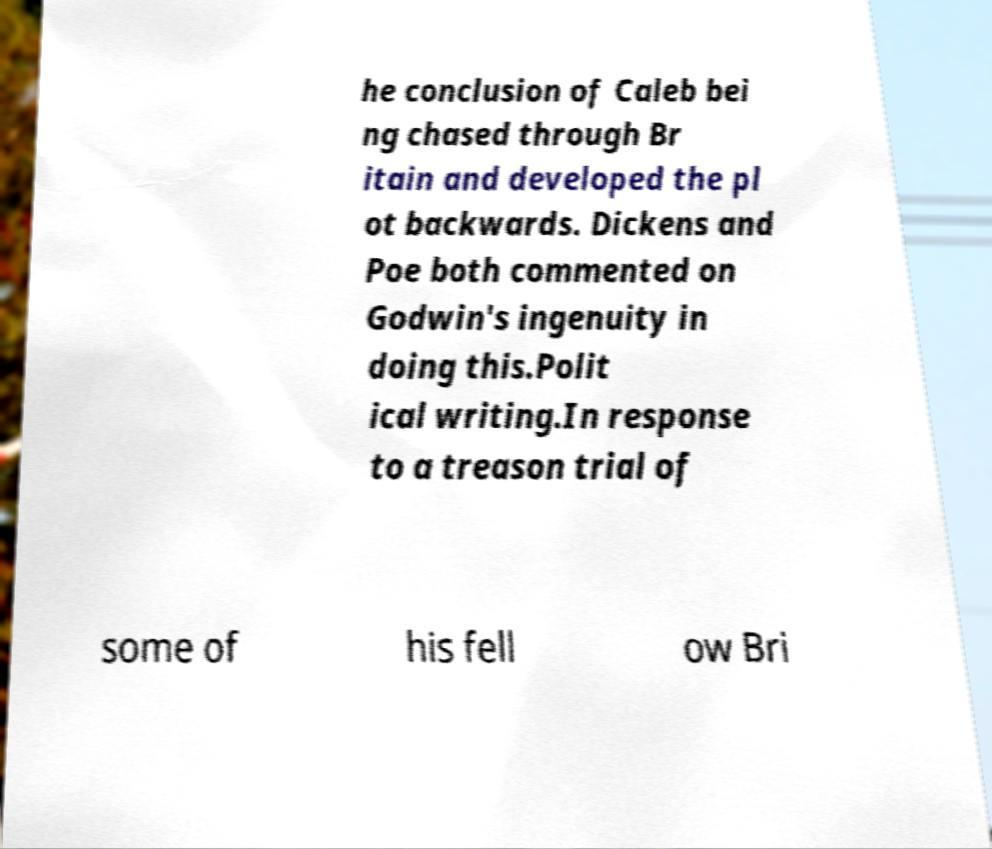Can you read and provide the text displayed in the image?This photo seems to have some interesting text. Can you extract and type it out for me? he conclusion of Caleb bei ng chased through Br itain and developed the pl ot backwards. Dickens and Poe both commented on Godwin's ingenuity in doing this.Polit ical writing.In response to a treason trial of some of his fell ow Bri 